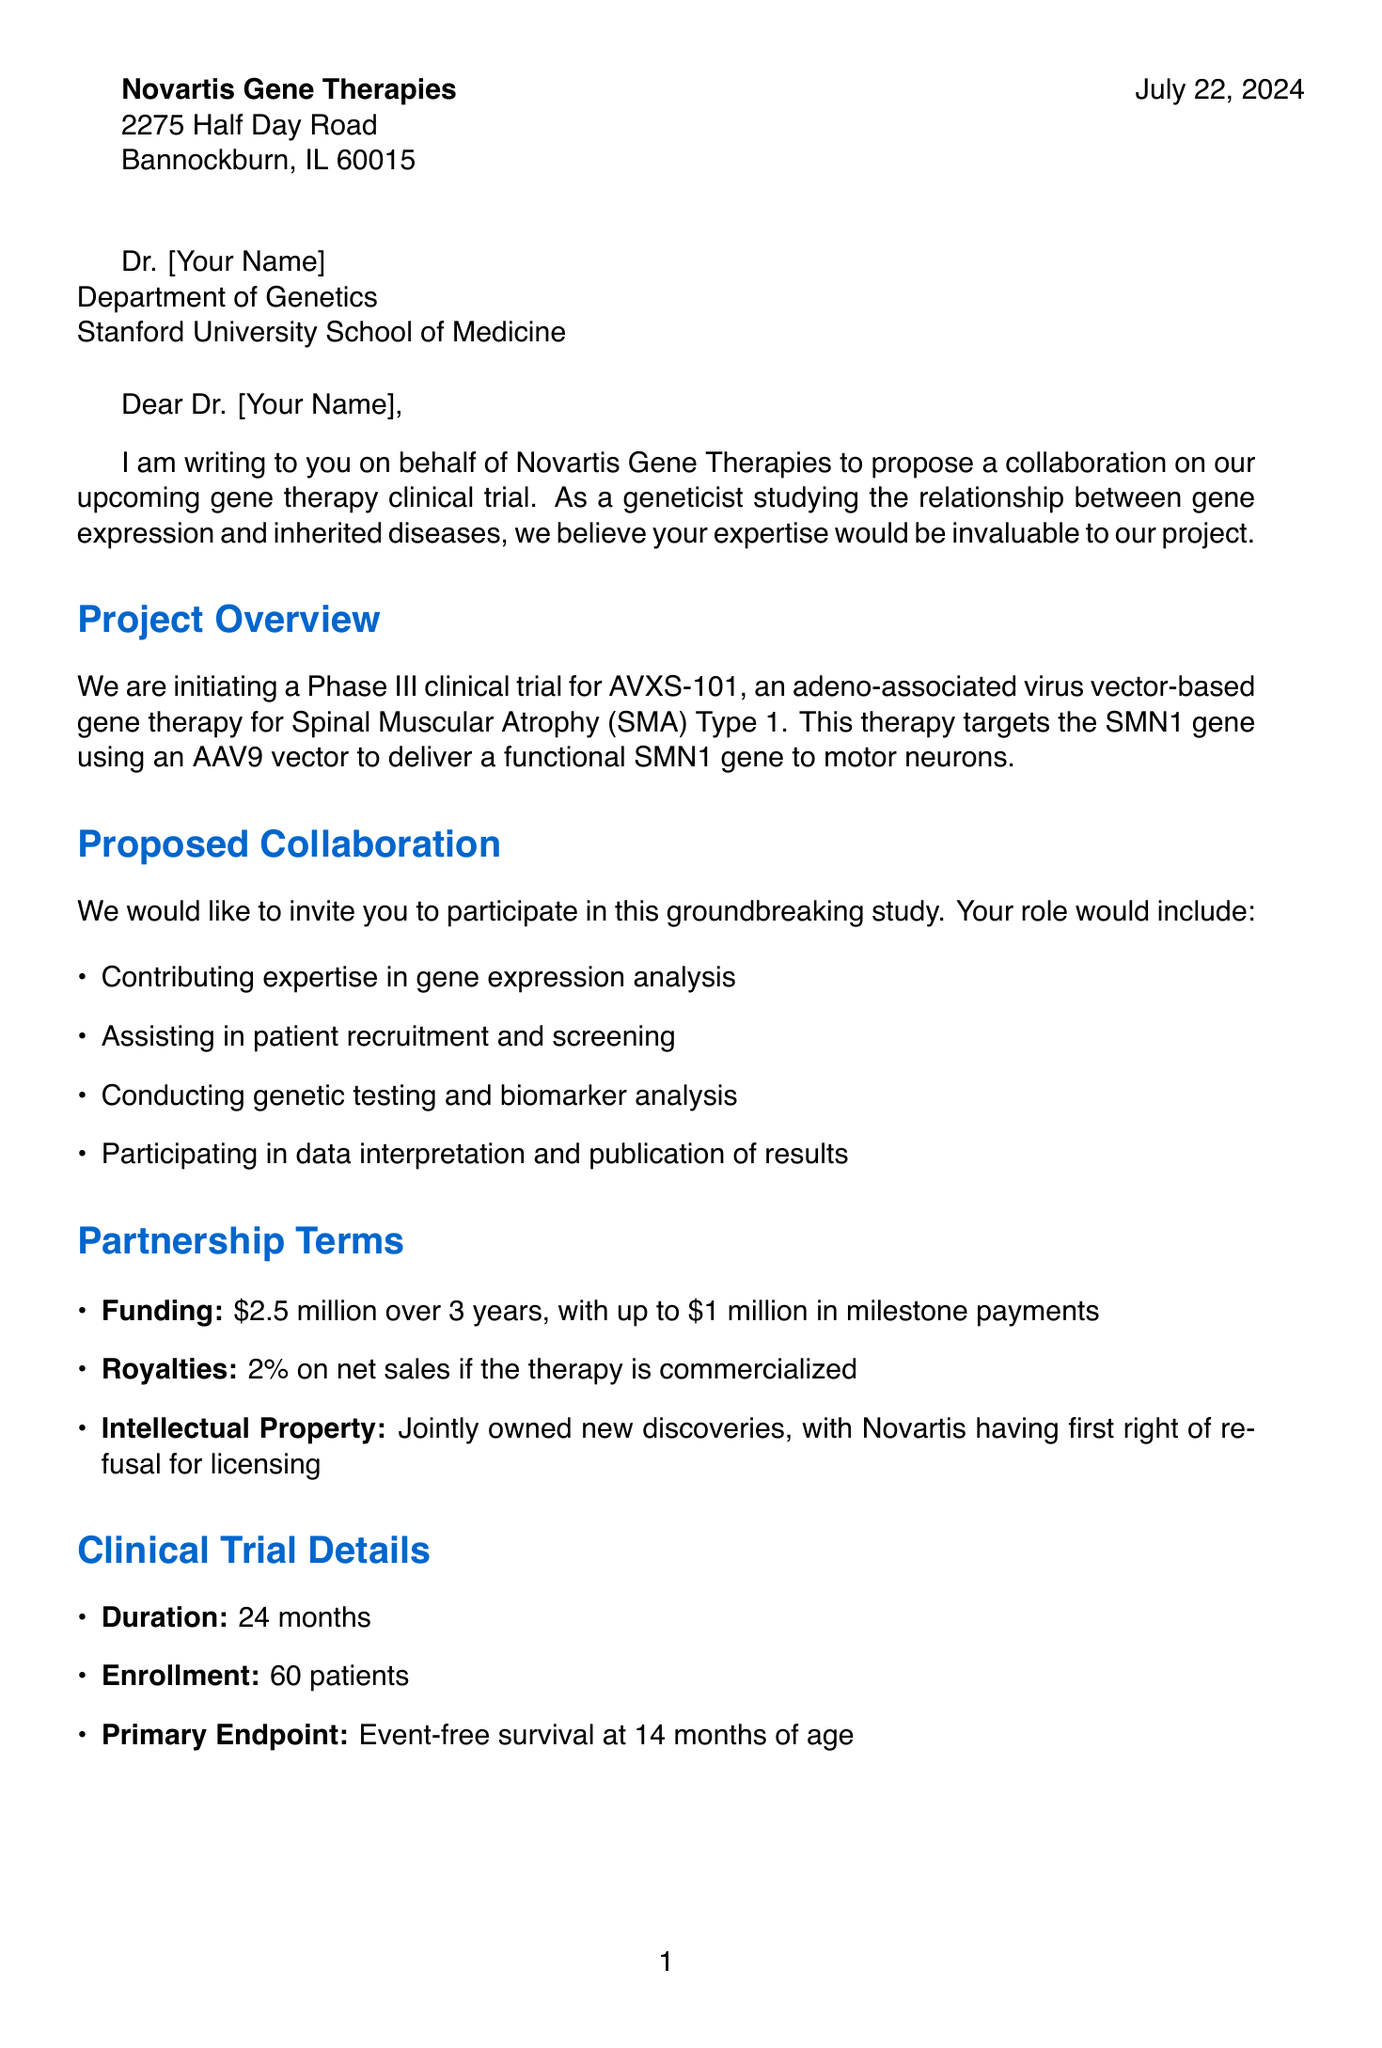What is the company name that sent the letter? The company name is mentioned at the top of the letter.
Answer: Novartis Gene Therapies Who is the contact person from Novartis? The contact person's name is specified in the sender's information in the letter.
Answer: Dr. Emily Chen What is the title of the proposed collaboration project? The project title is listed in the collaboration request section of the letter.
Answer: AVXS-101 Gene Therapy for Spinal Muscular Atrophy (SMA) Type 1 What is the financial funding amount offered for the research? The amount for research funding is explicitly stated in the partnership terms.
Answer: $2.5 million over 3 years How long is the estimated duration of the clinical trial? The duration of the clinical trial is provided in the clinical trial information section.
Answer: 24 months What is the primary endpoint of the clinical trial? The primary endpoint is specified in the clinical trial details section of the letter.
Answer: Event-free survival at 14 months of age What role does the academic partner have in the collaboration? The specific role of the academic partner is listed under proposed collaboration.
Answer: Contribute expertise in gene expression analysis What percentage of royalties is offered if the therapy is commercialized? The royalty percentage is detailed in the partnership terms.
Answer: 2% What is the urgency expressed in the closing remarks? The urgency is mentioned in the closing remarks about moving forward quickly.
Answer: Eager to move forward quickly What are the next steps suggested in the letter? The section details the next steps for both parties regarding the collaboration.
Answer: Review the proposed collaboration terms 